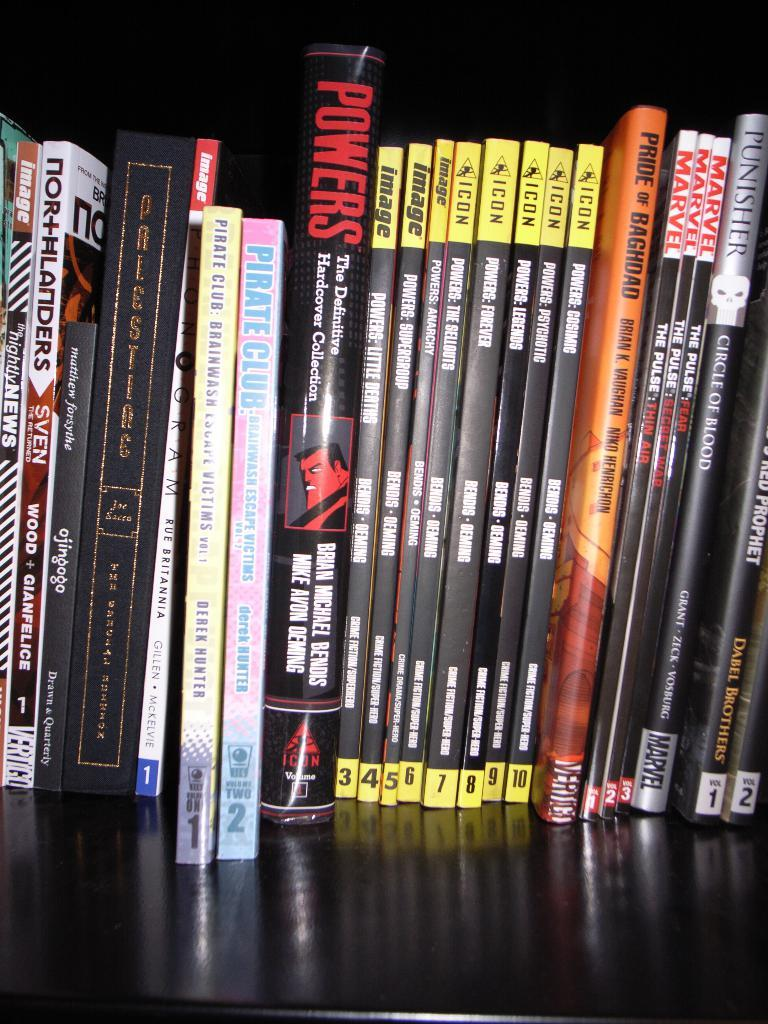<image>
Render a clear and concise summary of the photo. The book Pride of Baghdad sits next to many others on a shelf. 